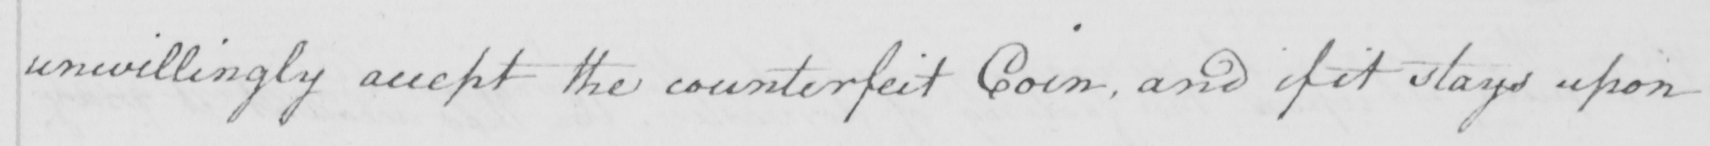Please provide the text content of this handwritten line. unwillingly accept the counterfeit Coin , and if it stays upon 